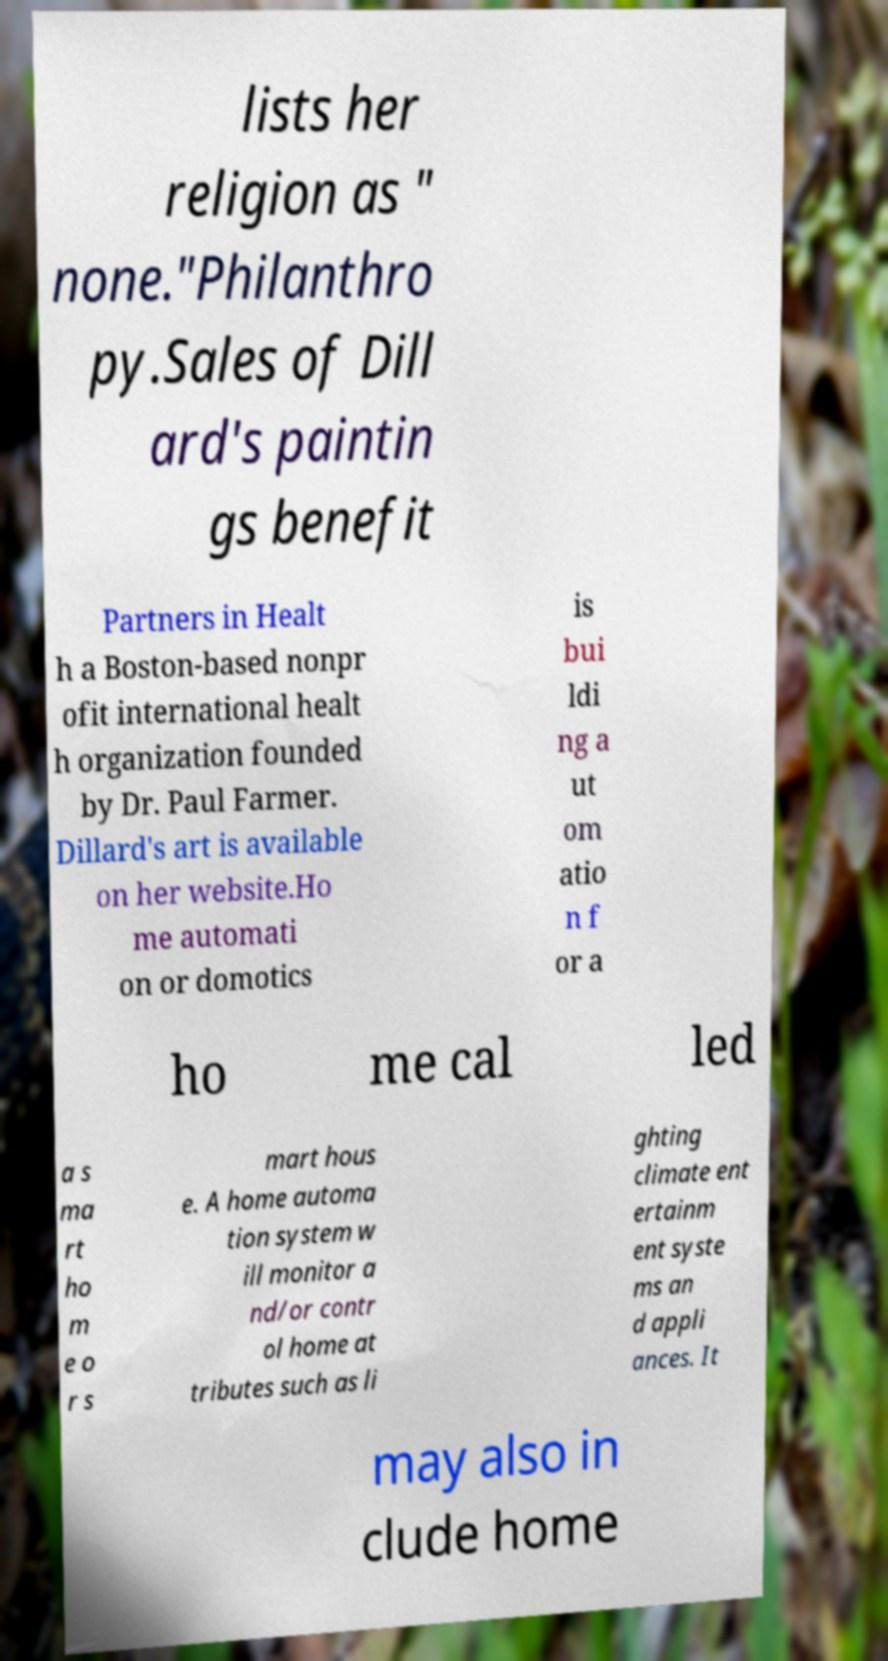I need the written content from this picture converted into text. Can you do that? lists her religion as " none."Philanthro py.Sales of Dill ard's paintin gs benefit Partners in Healt h a Boston-based nonpr ofit international healt h organization founded by Dr. Paul Farmer. Dillard's art is available on her website.Ho me automati on or domotics is bui ldi ng a ut om atio n f or a ho me cal led a s ma rt ho m e o r s mart hous e. A home automa tion system w ill monitor a nd/or contr ol home at tributes such as li ghting climate ent ertainm ent syste ms an d appli ances. It may also in clude home 